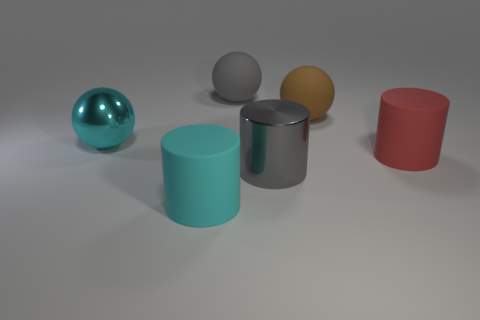Add 3 cyan objects. How many objects exist? 9 Add 4 cyan objects. How many cyan objects exist? 6 Subtract 0 cyan blocks. How many objects are left? 6 Subtract all cyan matte cylinders. Subtract all cyan metallic things. How many objects are left? 4 Add 1 big cyan spheres. How many big cyan spheres are left? 2 